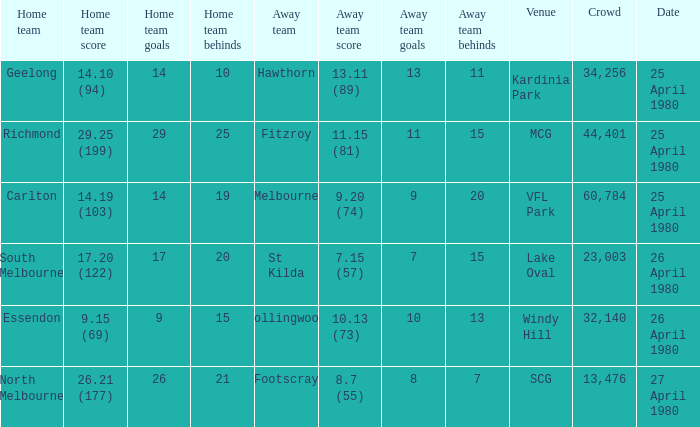What wa the date of the North Melbourne home game? 27 April 1980. 